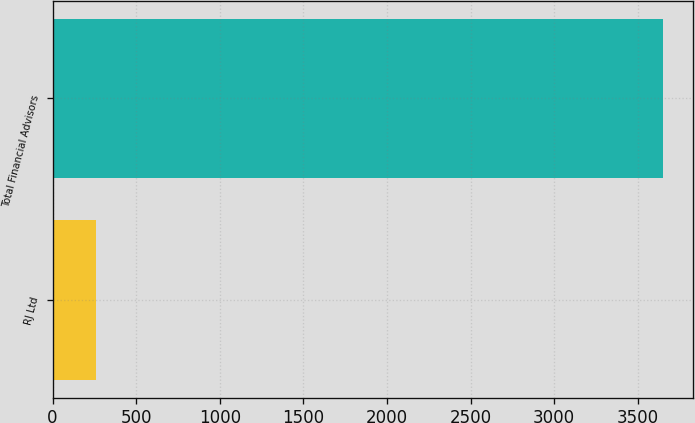<chart> <loc_0><loc_0><loc_500><loc_500><bar_chart><fcel>RJ Ltd<fcel>Total Financial Advisors<nl><fcel>257<fcel>3651<nl></chart> 